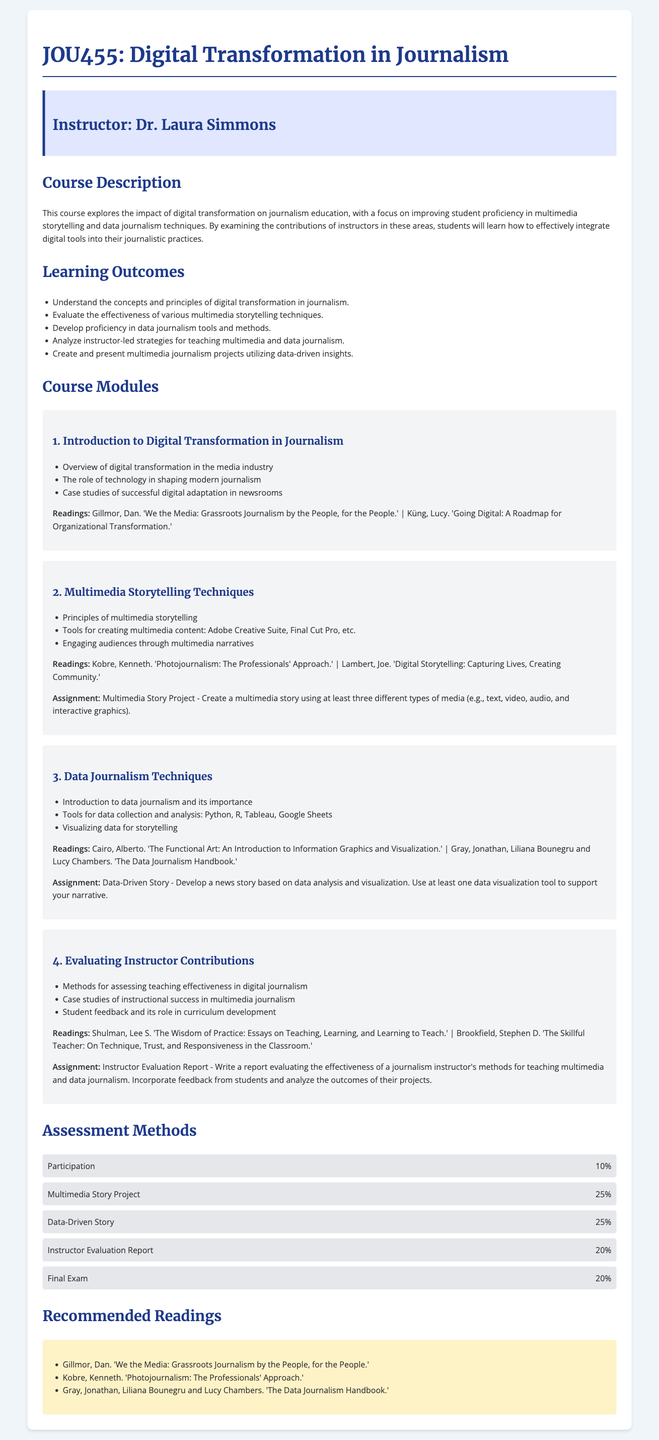What is the course title? The course title is listed at the beginning of the syllabus.
Answer: JOU455: Digital Transformation in Journalism Who is the instructor? The instructor's name is provided in the instructor information section.
Answer: Dr. Laura Simmons What is the percentage weight of the final exam? The percentage weight is indicated in the assessment methods section.
Answer: 20% What is one of the readings for the Data Journalism Techniques module? The readings for each module are listed under each respective section.
Answer: The Functional Art: An Introduction to Information Graphics and Visualization What assignment is associated with the Multimedia Storytelling Techniques module? Each module includes an assignment related to its content.
Answer: Multimedia Story Project Name a tool used for data collection and analysis in the Data Journalism Techniques module. The tools are listed in an introductory item within the module.
Answer: Python What learning outcome focuses on multimedia storytelling? Learning outcomes are listed and detail what students will achieve in the course.
Answer: Evaluate the effectiveness of various multimedia storytelling techniques Which module discusses evaluating instructor contributions? The course modules are sequentially numbered and titled in the syllabus.
Answer: Module 4: Evaluating Instructor Contributions 